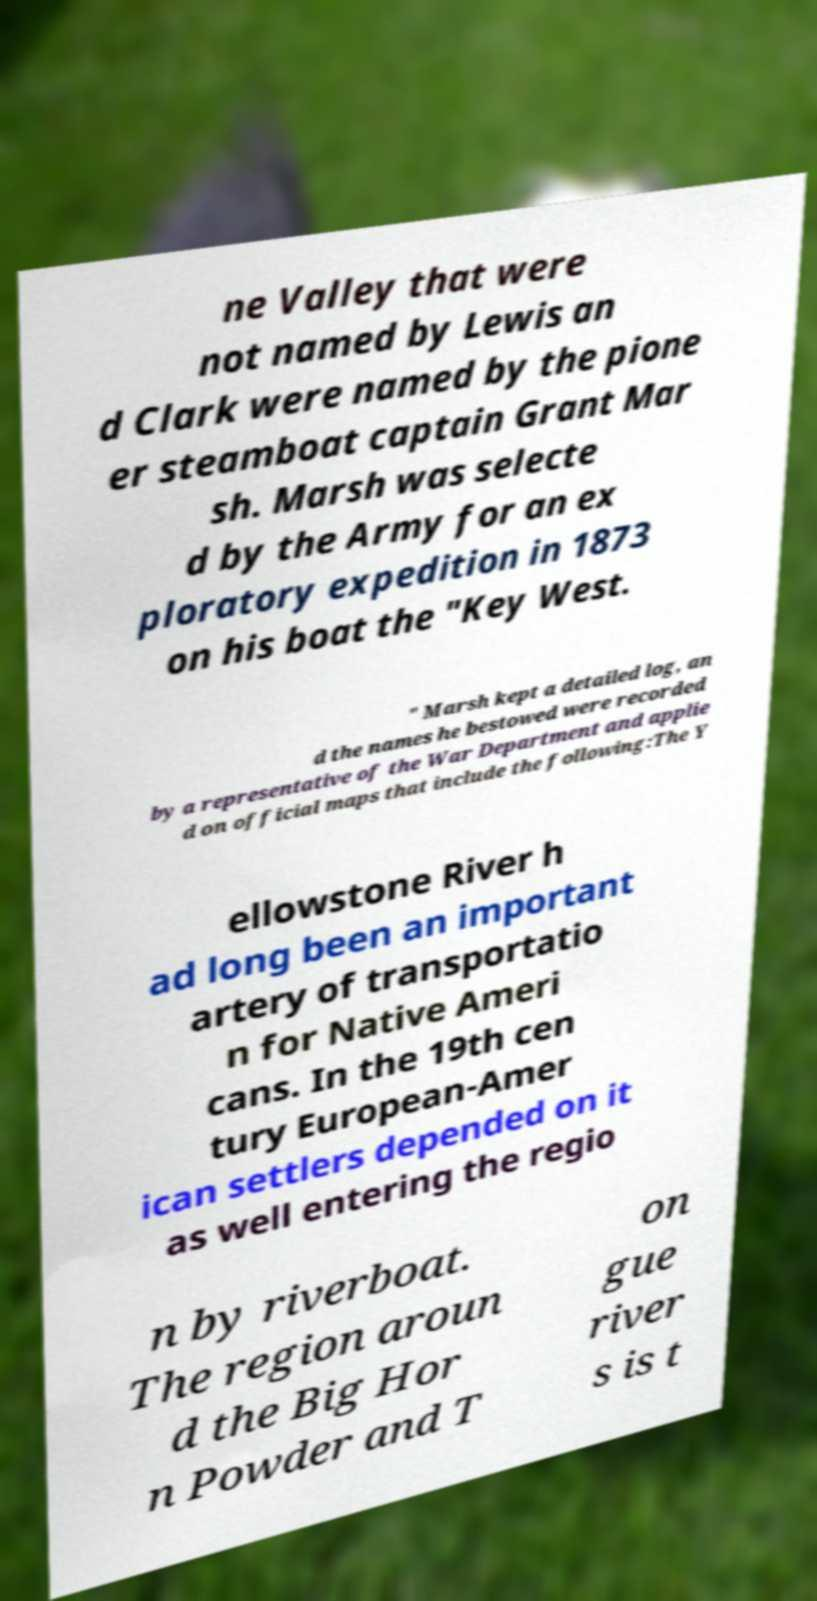Can you read and provide the text displayed in the image?This photo seems to have some interesting text. Can you extract and type it out for me? ne Valley that were not named by Lewis an d Clark were named by the pione er steamboat captain Grant Mar sh. Marsh was selecte d by the Army for an ex ploratory expedition in 1873 on his boat the "Key West. " Marsh kept a detailed log, an d the names he bestowed were recorded by a representative of the War Department and applie d on official maps that include the following:The Y ellowstone River h ad long been an important artery of transportatio n for Native Ameri cans. In the 19th cen tury European-Amer ican settlers depended on it as well entering the regio n by riverboat. The region aroun d the Big Hor n Powder and T on gue river s is t 